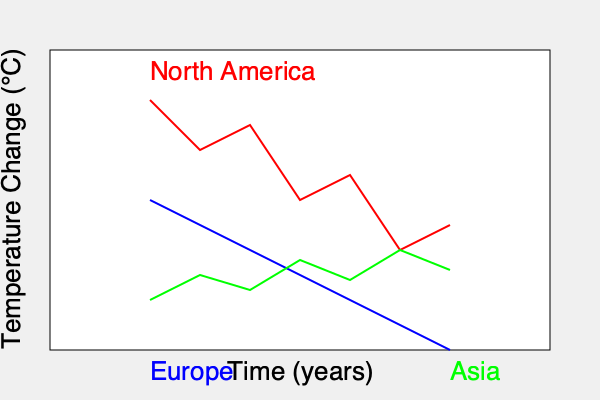Based on the climate change impact graph showing temperature changes across different regions over time, which region is projected to experience the most significant temperature increase, and how might this affect diplomatic negotiations on emissions reduction targets? To answer this question, let's analyze the graph step-by-step:

1. The graph shows temperature changes over time for three regions: North America (red), Europe (blue), and Asia (green).

2. Comparing the slopes of the lines:
   - North America (red) shows the steepest upward trend.
   - Europe (blue) shows a steady but less steep upward trend.
   - Asia (green) shows a fluctuating trend with a slight overall increase.

3. The steeper the slope, the more rapid the temperature increase. North America's line has the steepest slope, indicating the most significant projected temperature increase.

4. Impact on diplomatic negotiations:
   a) North America, facing the most severe projected impacts, may be under pressure to commit to more ambitious emissions reduction targets.
   b) Europe, with a steady increase, might maintain its current stance on emissions reductions.
   c) Asia, with a less severe trend, might argue for more lenient targets based on their lower projected impact.

5. As a UN official, you would need to consider:
   - The urgency of action required for North America.
   - The potential for North America to lead by example in emissions reductions.
   - The need to engage Asia in more aggressive mitigation efforts despite their lower projected impact.
   - The possibility of using Europe's steady approach as a baseline for global targets.

6. These differing regional impacts could lead to complex negotiations, where countries might argue for differentiated responsibilities based on their projected climate change effects.
Answer: North America; increased pressure for ambitious targets, potential regional disagreements on responsibility levels. 